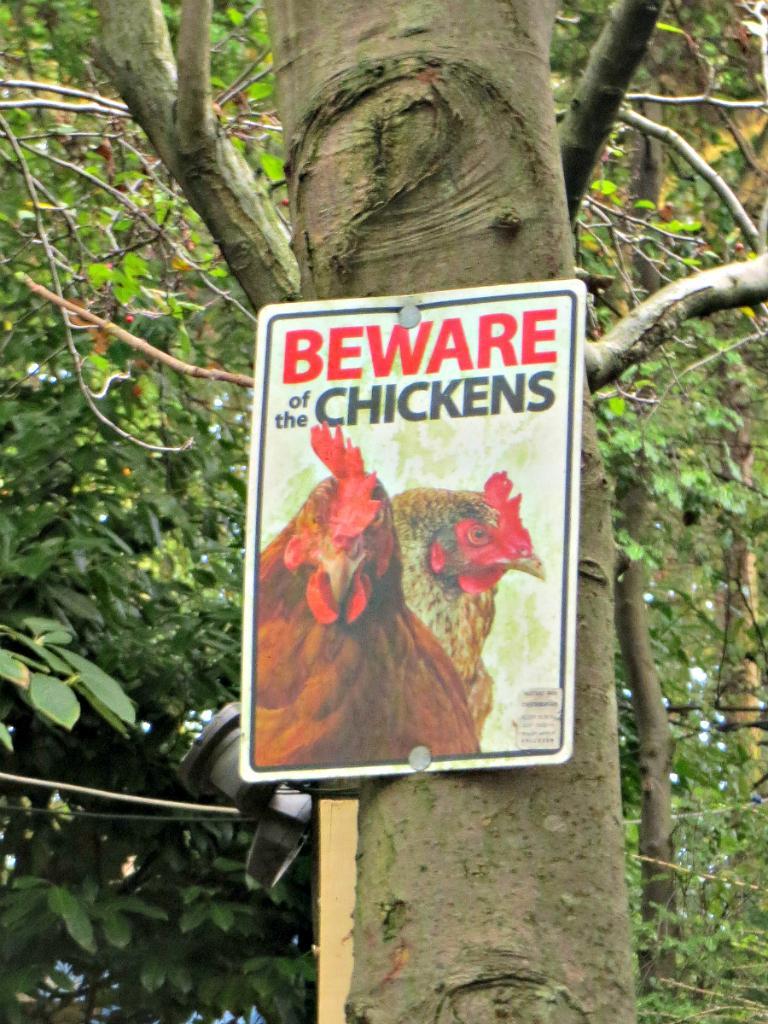Could you give a brief overview of what you see in this image? In the image in the center, we can see trees and one banner. On the banner, it is written as "Beware Of The Chickens". 